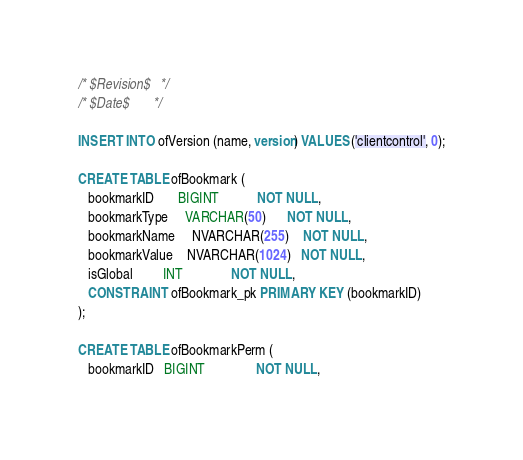Convert code to text. <code><loc_0><loc_0><loc_500><loc_500><_SQL_>/* $Revision$   */
/* $Date$       */

INSERT INTO ofVersion (name, version) VALUES ('clientcontrol', 0);

CREATE TABLE ofBookmark (
   bookmarkID       BIGINT           NOT NULL,
   bookmarkType     VARCHAR(50)      NOT NULL,
   bookmarkName     NVARCHAR(255)    NOT NULL,
   bookmarkValue    NVARCHAR(1024)   NOT NULL,
   isGlobal         INT              NOT NULL,
   CONSTRAINT ofBookmark_pk PRIMARY KEY (bookmarkID)
);

CREATE TABLE ofBookmarkPerm (
   bookmarkID   BIGINT               NOT NULL,</code> 